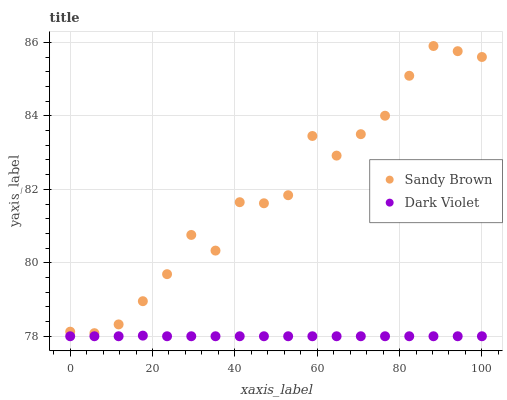Does Dark Violet have the minimum area under the curve?
Answer yes or no. Yes. Does Sandy Brown have the maximum area under the curve?
Answer yes or no. Yes. Does Dark Violet have the maximum area under the curve?
Answer yes or no. No. Is Dark Violet the smoothest?
Answer yes or no. Yes. Is Sandy Brown the roughest?
Answer yes or no. Yes. Is Dark Violet the roughest?
Answer yes or no. No. Does Dark Violet have the lowest value?
Answer yes or no. Yes. Does Sandy Brown have the highest value?
Answer yes or no. Yes. Does Dark Violet have the highest value?
Answer yes or no. No. Is Dark Violet less than Sandy Brown?
Answer yes or no. Yes. Is Sandy Brown greater than Dark Violet?
Answer yes or no. Yes. Does Dark Violet intersect Sandy Brown?
Answer yes or no. No. 